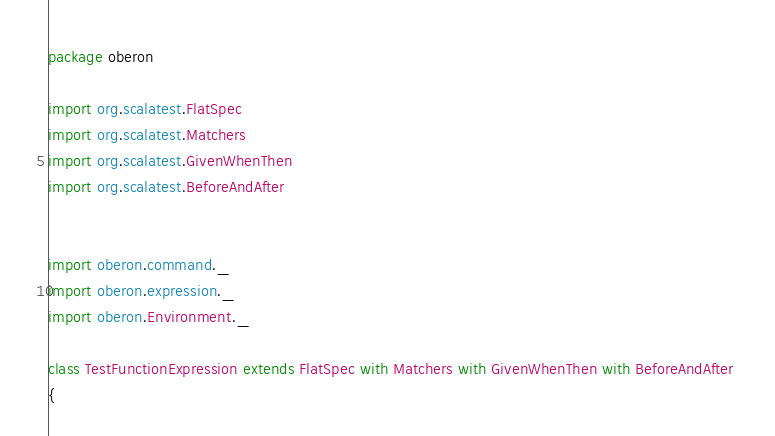<code> <loc_0><loc_0><loc_500><loc_500><_Scala_>package oberon

import org.scalatest.FlatSpec
import org.scalatest.Matchers
import org.scalatest.GivenWhenThen
import org.scalatest.BeforeAndAfter


import oberon.command._
import oberon.expression._
import oberon.Environment._

class TestFunctionExpression extends FlatSpec with Matchers with GivenWhenThen with BeforeAndAfter 
{
</code> 